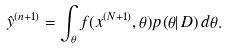Convert formula to latex. <formula><loc_0><loc_0><loc_500><loc_500>\hat { y } ^ { ( n + 1 ) } = \int _ { \theta } f ( x ^ { ( N + 1 ) } , \theta ) p ( \theta | \, D ) \, d \theta .</formula> 